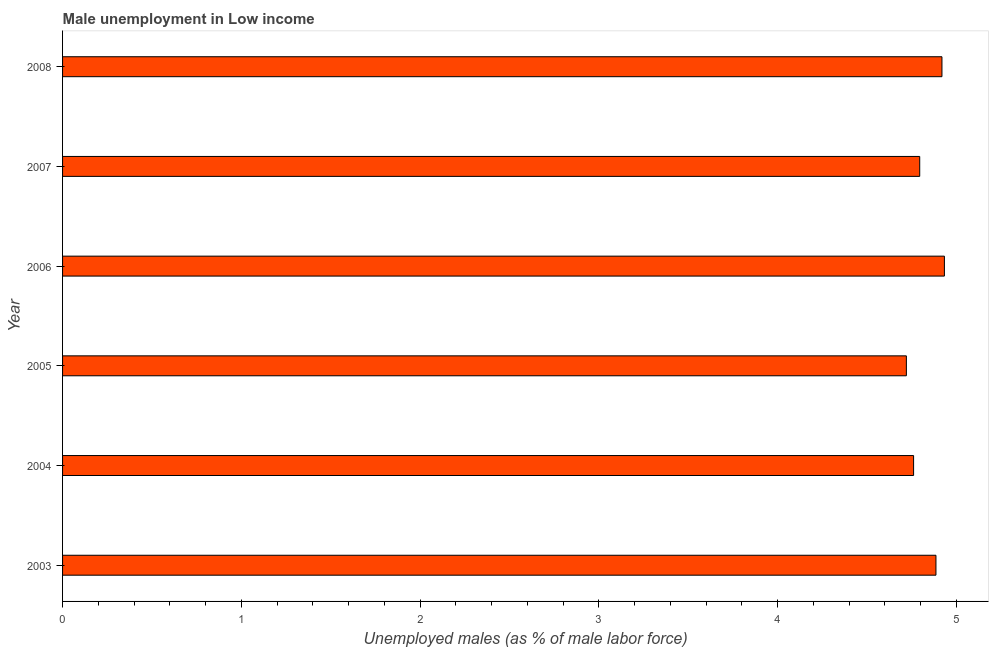Does the graph contain any zero values?
Give a very brief answer. No. What is the title of the graph?
Make the answer very short. Male unemployment in Low income. What is the label or title of the X-axis?
Make the answer very short. Unemployed males (as % of male labor force). What is the unemployed males population in 2007?
Offer a very short reply. 4.79. Across all years, what is the maximum unemployed males population?
Your answer should be very brief. 4.93. Across all years, what is the minimum unemployed males population?
Provide a succinct answer. 4.72. In which year was the unemployed males population maximum?
Ensure brevity in your answer.  2006. What is the sum of the unemployed males population?
Keep it short and to the point. 29.01. What is the difference between the unemployed males population in 2004 and 2006?
Give a very brief answer. -0.17. What is the average unemployed males population per year?
Your response must be concise. 4.83. What is the median unemployed males population?
Offer a very short reply. 4.84. Do a majority of the years between 2008 and 2004 (inclusive) have unemployed males population greater than 4.8 %?
Your answer should be compact. Yes. What is the difference between the highest and the second highest unemployed males population?
Your answer should be very brief. 0.01. What is the difference between the highest and the lowest unemployed males population?
Keep it short and to the point. 0.21. In how many years, is the unemployed males population greater than the average unemployed males population taken over all years?
Keep it short and to the point. 3. Are all the bars in the graph horizontal?
Keep it short and to the point. Yes. How many years are there in the graph?
Offer a terse response. 6. What is the difference between two consecutive major ticks on the X-axis?
Provide a succinct answer. 1. Are the values on the major ticks of X-axis written in scientific E-notation?
Provide a short and direct response. No. What is the Unemployed males (as % of male labor force) of 2003?
Provide a succinct answer. 4.89. What is the Unemployed males (as % of male labor force) of 2004?
Give a very brief answer. 4.76. What is the Unemployed males (as % of male labor force) of 2005?
Your answer should be compact. 4.72. What is the Unemployed males (as % of male labor force) in 2006?
Provide a succinct answer. 4.93. What is the Unemployed males (as % of male labor force) in 2007?
Offer a terse response. 4.79. What is the Unemployed males (as % of male labor force) in 2008?
Your answer should be very brief. 4.92. What is the difference between the Unemployed males (as % of male labor force) in 2003 and 2004?
Your response must be concise. 0.13. What is the difference between the Unemployed males (as % of male labor force) in 2003 and 2005?
Provide a succinct answer. 0.17. What is the difference between the Unemployed males (as % of male labor force) in 2003 and 2006?
Ensure brevity in your answer.  -0.05. What is the difference between the Unemployed males (as % of male labor force) in 2003 and 2007?
Provide a succinct answer. 0.09. What is the difference between the Unemployed males (as % of male labor force) in 2003 and 2008?
Make the answer very short. -0.03. What is the difference between the Unemployed males (as % of male labor force) in 2004 and 2005?
Ensure brevity in your answer.  0.04. What is the difference between the Unemployed males (as % of male labor force) in 2004 and 2006?
Provide a short and direct response. -0.17. What is the difference between the Unemployed males (as % of male labor force) in 2004 and 2007?
Your answer should be compact. -0.03. What is the difference between the Unemployed males (as % of male labor force) in 2004 and 2008?
Your response must be concise. -0.16. What is the difference between the Unemployed males (as % of male labor force) in 2005 and 2006?
Give a very brief answer. -0.21. What is the difference between the Unemployed males (as % of male labor force) in 2005 and 2007?
Your response must be concise. -0.07. What is the difference between the Unemployed males (as % of male labor force) in 2005 and 2008?
Your response must be concise. -0.2. What is the difference between the Unemployed males (as % of male labor force) in 2006 and 2007?
Offer a terse response. 0.14. What is the difference between the Unemployed males (as % of male labor force) in 2006 and 2008?
Ensure brevity in your answer.  0.01. What is the difference between the Unemployed males (as % of male labor force) in 2007 and 2008?
Offer a very short reply. -0.12. What is the ratio of the Unemployed males (as % of male labor force) in 2003 to that in 2005?
Provide a short and direct response. 1.03. What is the ratio of the Unemployed males (as % of male labor force) in 2003 to that in 2006?
Provide a succinct answer. 0.99. What is the ratio of the Unemployed males (as % of male labor force) in 2003 to that in 2008?
Ensure brevity in your answer.  0.99. What is the ratio of the Unemployed males (as % of male labor force) in 2004 to that in 2005?
Your response must be concise. 1.01. What is the ratio of the Unemployed males (as % of male labor force) in 2004 to that in 2007?
Your answer should be compact. 0.99. What is the ratio of the Unemployed males (as % of male labor force) in 2005 to that in 2007?
Ensure brevity in your answer.  0.98. What is the ratio of the Unemployed males (as % of male labor force) in 2005 to that in 2008?
Keep it short and to the point. 0.96. 